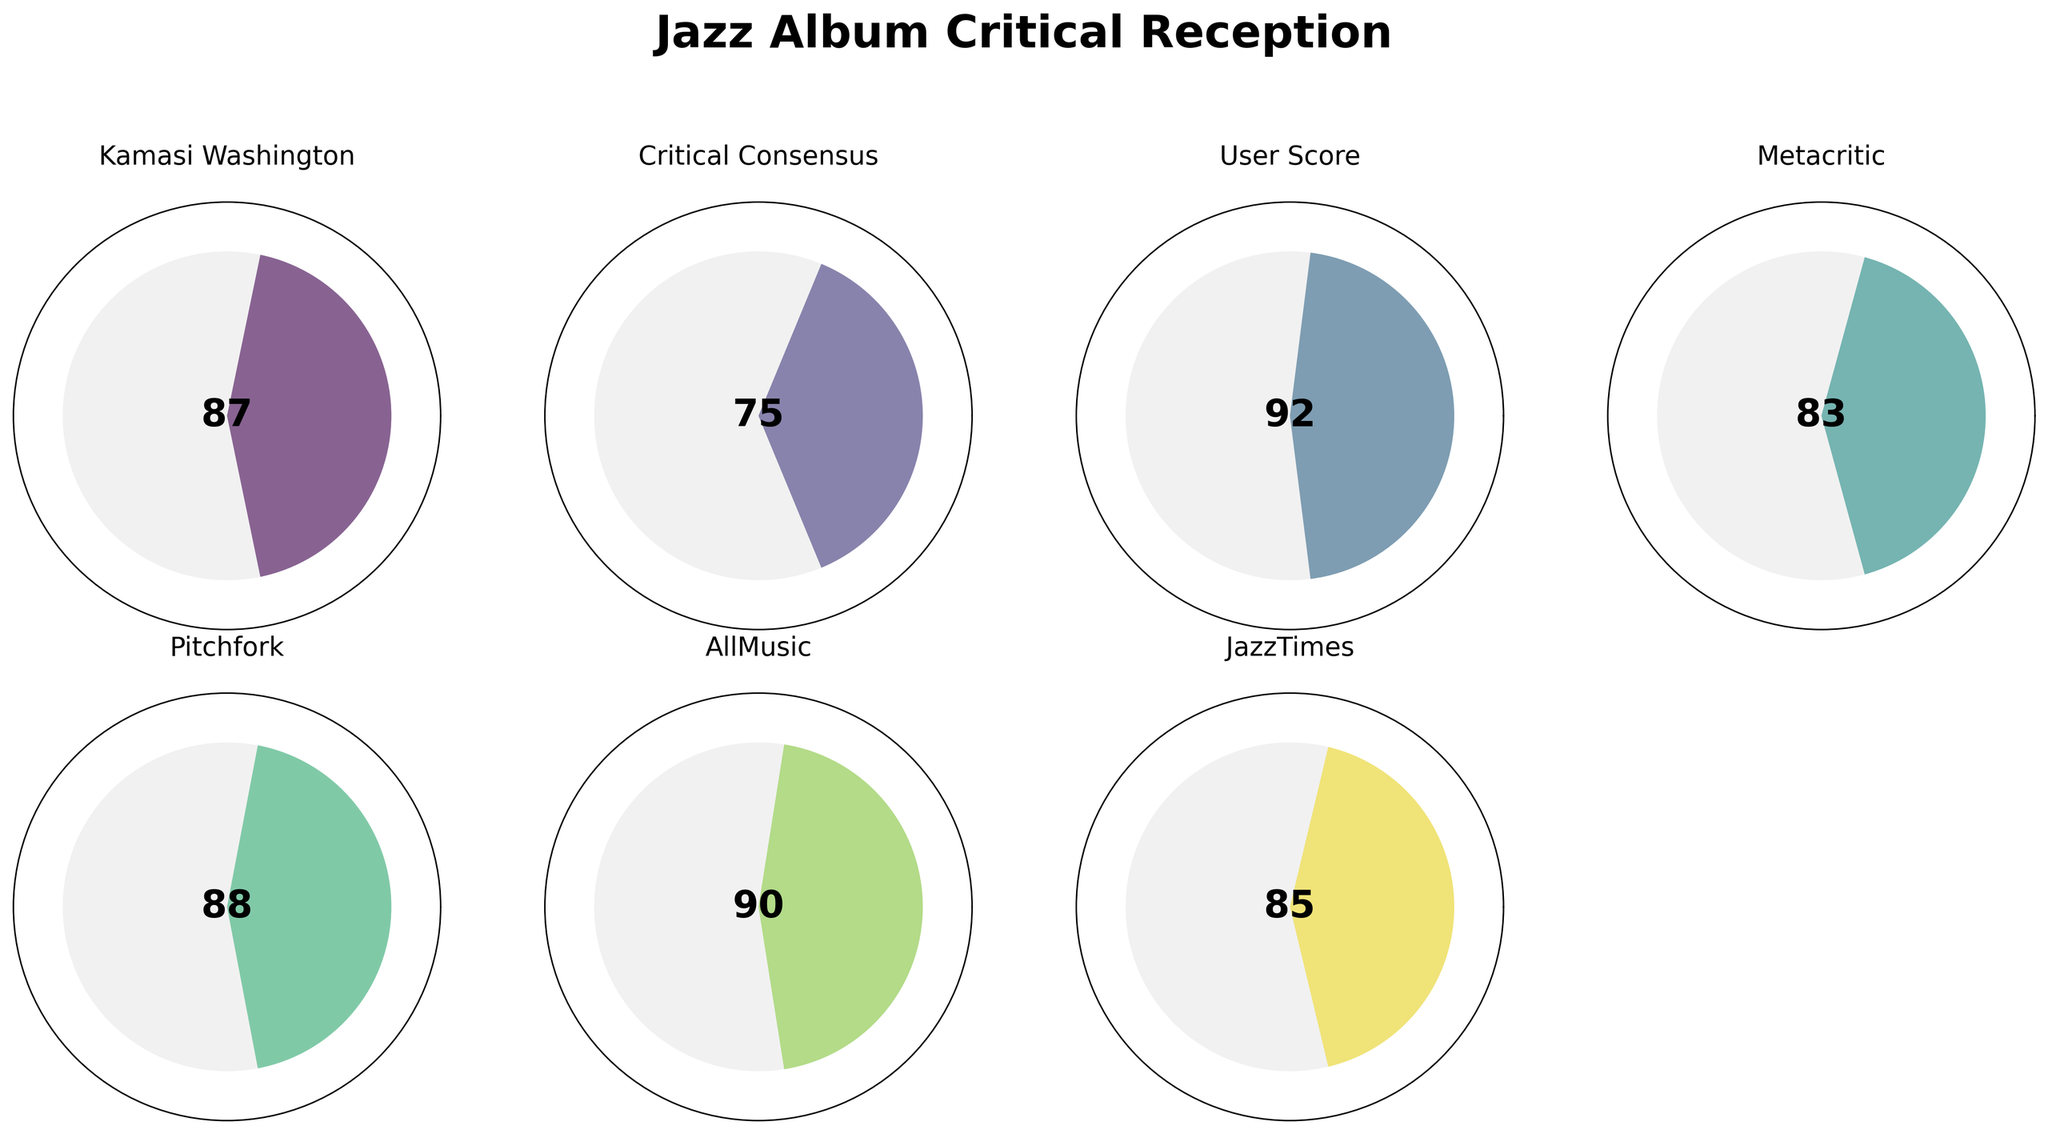What's the title of the figure? The title text is prominently displayed at the top of the figure.
Answer: Jazz Album Critical Reception How many sources provided ratings for Kamasi Washington's album? By counting the number of subplots, each with its own rating, we can determine the number of sources.
Answer: 6 What is the highest rating given to the album? We need to compare all the shown ratings and identify the maximum value.
Answer: 92 Which source gave the lowest rating to the album? We need to look at all the ratings and identify the source with the smallest number.
Answer: Critical Consensus What's the average rating across all sources? Add all the ratings (87, 75, 92, 83, 88, 90, 85), and then divide by the number of ratings (7). (87 + 75 + 92 + 83 + 88 + 90 + 85) / 7 = 600 / 7 ≈ 85.71
Answer: 85.7 By how many points does the User Score exceed the Critical Consensus rating? Subtract the Critical Consensus rating from the User Score. 92 - 75 = 17
Answer: 17 What is the second highest rating given and by which source? Compare the ratings and find the second highest value and its source. The highest is 92 by User Score, and the second highest is 90 by AllMusic.
Answer: AllMusic Which ratings are above the overall average rating? First calculate the average rating which is approximately 85.7. Then identify all ratings above this value: User Score (92), Pitchfork (88), AllMusic (90), JazzTimes (85)
Answer: User Score, Pitchfork, AllMusic Which rating is closest to the median rating? Organize the ratings in ascending order (75, 83, 85, 87, 88, 90, 92). The median of these ratings is 87, which is Kamasi Washington's rating.
Answer: Kamasi Washington What's the range of the ratings given to the album? Subtract the minimum rating from the maximum rating. 92 (maximum) - 75 (minimum) = 17
Answer: 17 